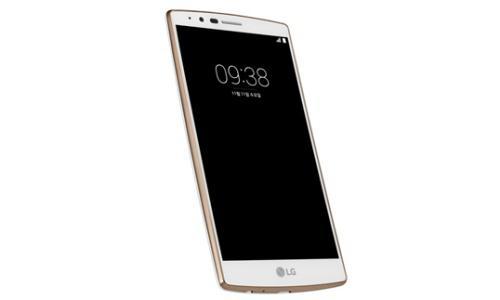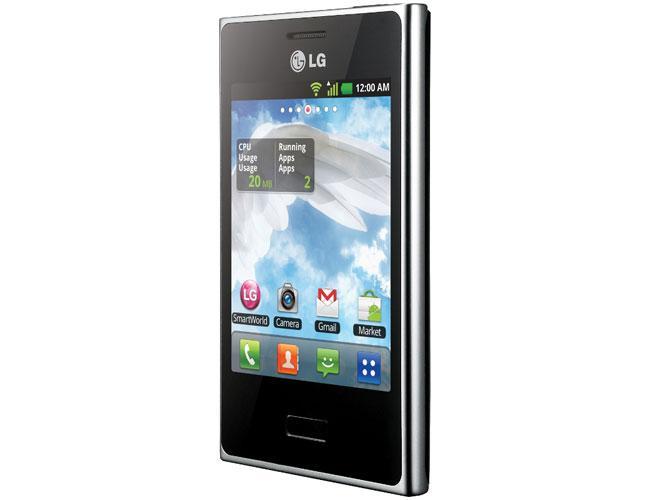The first image is the image on the left, the second image is the image on the right. For the images shown, is this caption "The right image shows a wallet phone case that is open with no cell phone in it." true? Answer yes or no. No. The first image is the image on the left, the second image is the image on the right. Examine the images to the left and right. Is the description "The left and right image contains the same number of cell phones." accurate? Answer yes or no. Yes. 